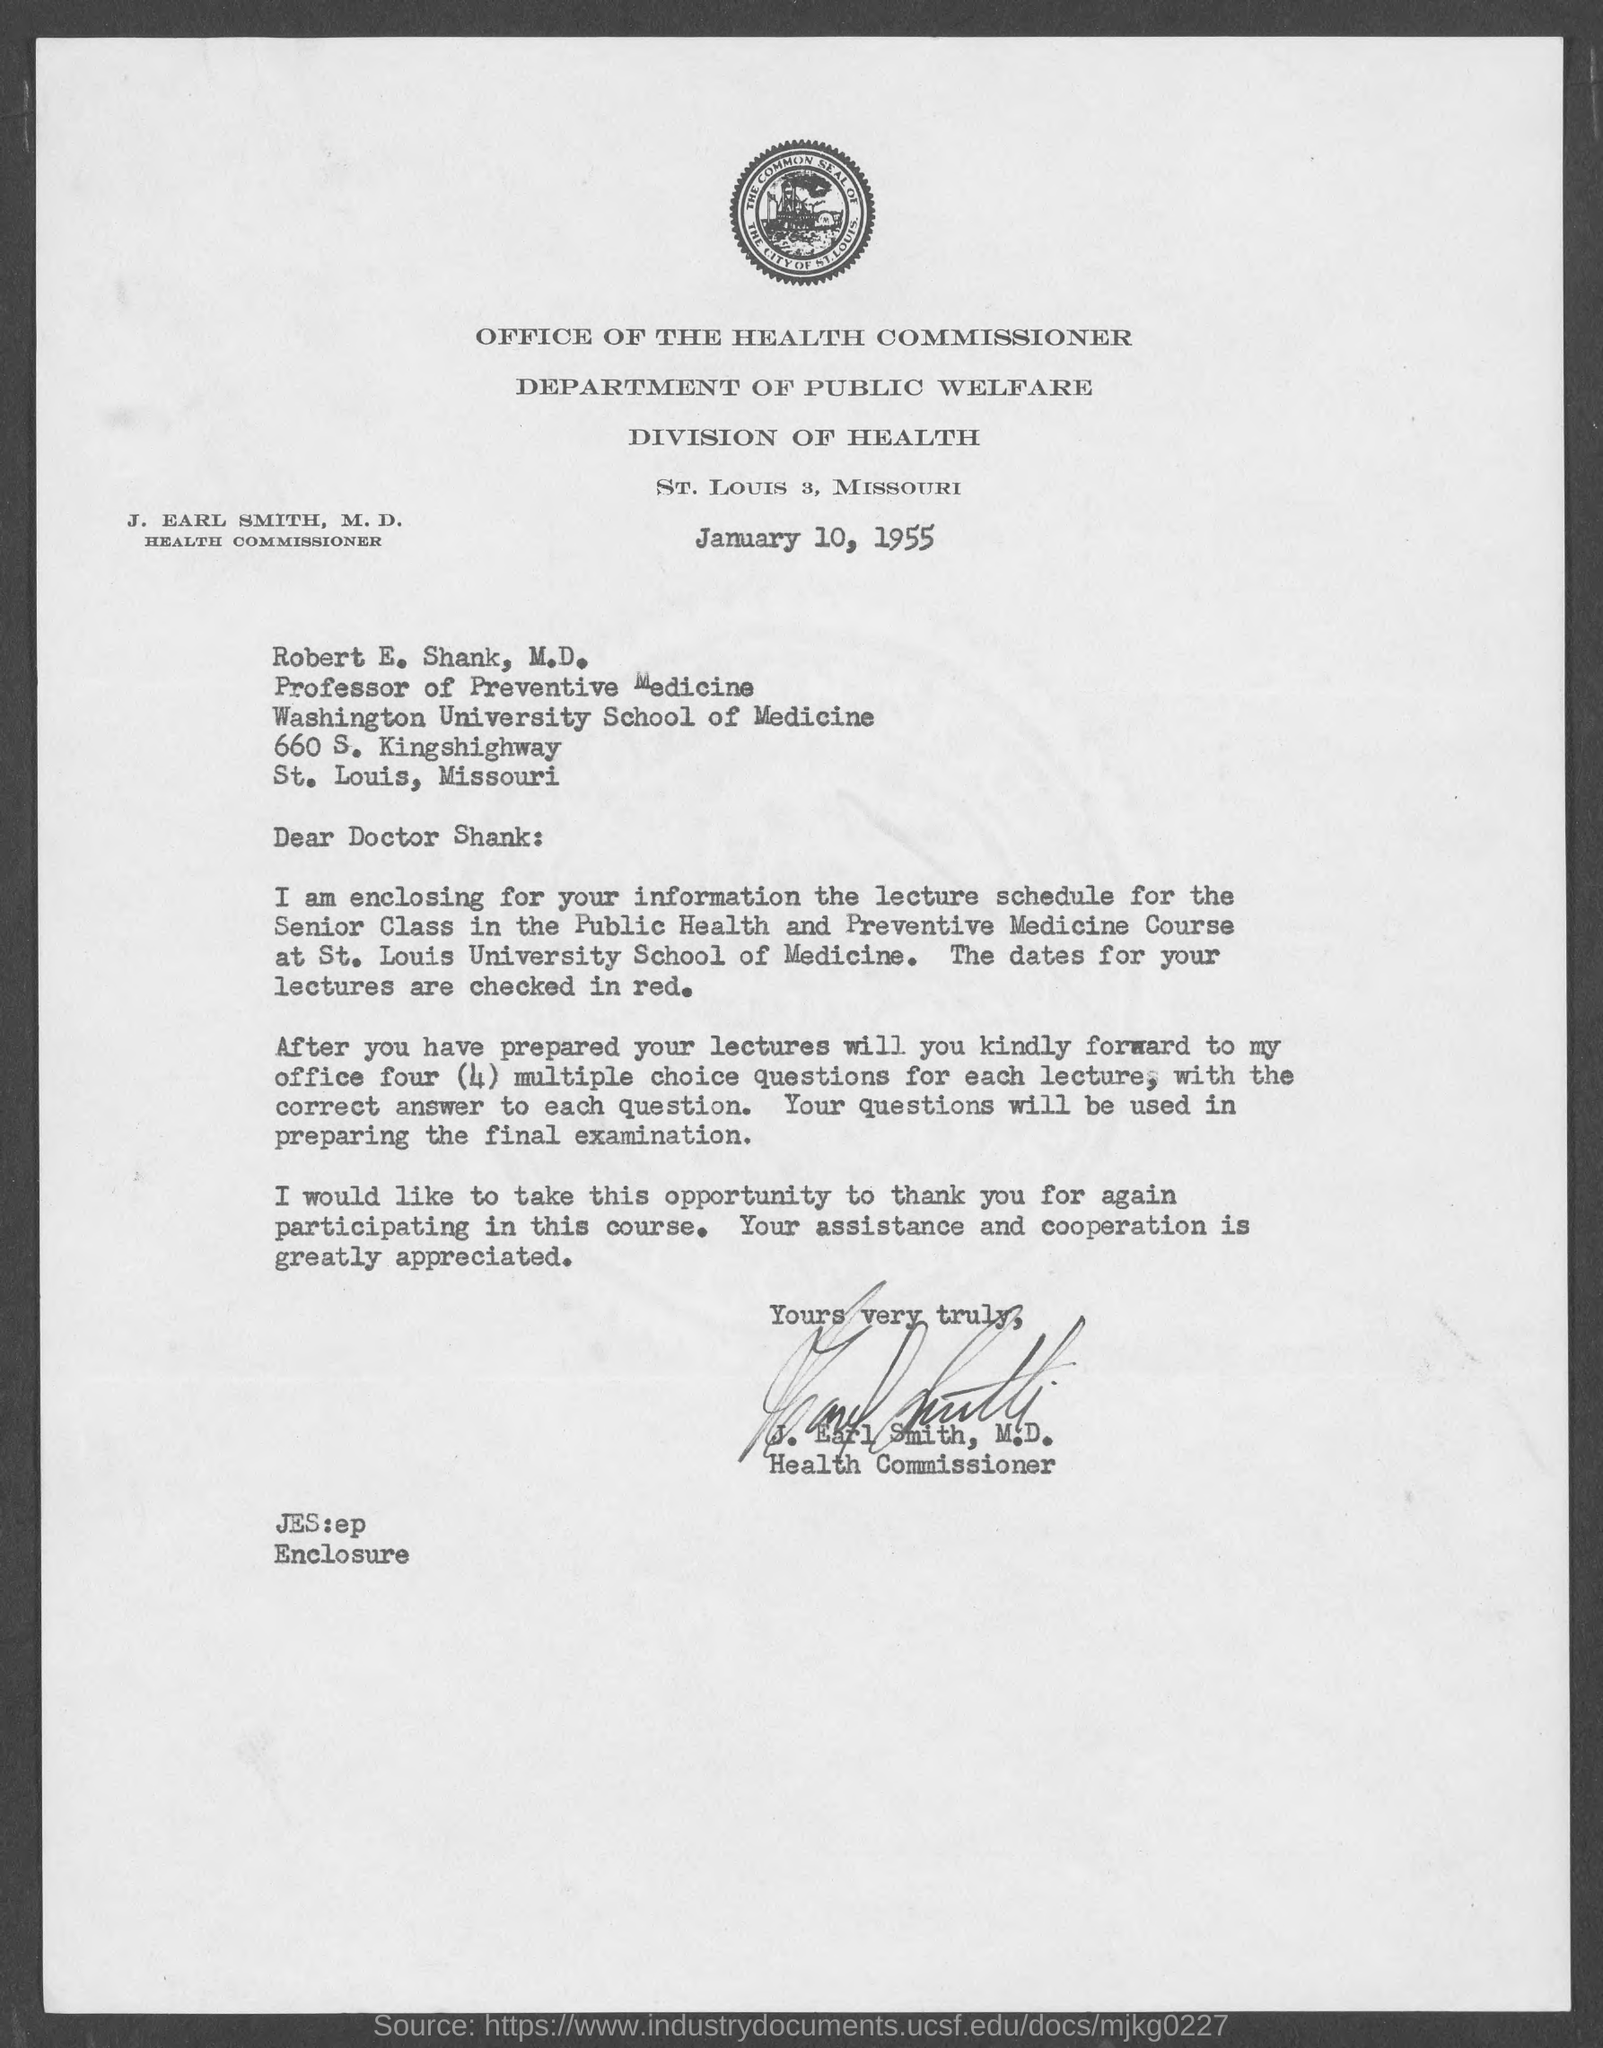Identify some key points in this picture. The letter is addressed to Robert E. Shank, M.D. Dr. Robert E. Shank, M.D., is affiliated with Washington University School of Medicine. The letter was written by J. Earl Smith, M.D. The date of the letter is January 10, 1955. The location of the Division of Health in St. Louis, Missouri, is the Division of Health in St. Louis, Missouri. 